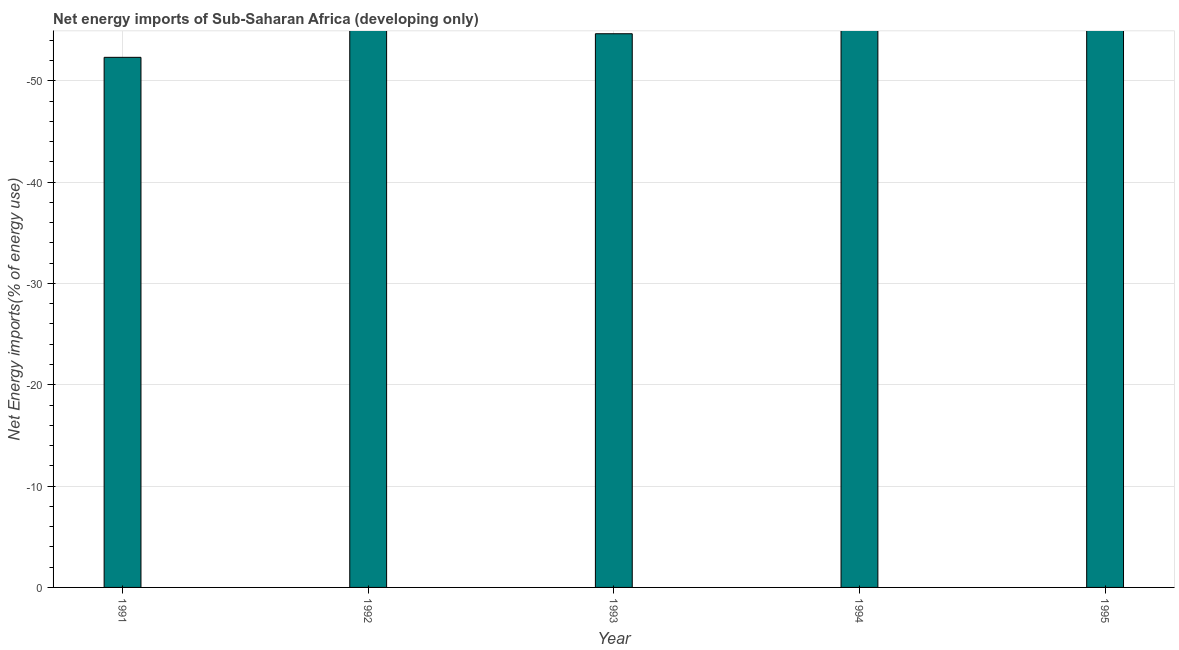Does the graph contain any zero values?
Provide a short and direct response. Yes. Does the graph contain grids?
Your answer should be very brief. Yes. What is the title of the graph?
Ensure brevity in your answer.  Net energy imports of Sub-Saharan Africa (developing only). What is the label or title of the Y-axis?
Offer a very short reply. Net Energy imports(% of energy use). In how many years, is the energy imports greater than the average energy imports taken over all years?
Make the answer very short. 0. How many bars are there?
Make the answer very short. 0. How many years are there in the graph?
Your answer should be very brief. 5. Are the values on the major ticks of Y-axis written in scientific E-notation?
Offer a terse response. No. What is the Net Energy imports(% of energy use) of 1992?
Your answer should be compact. 0. 